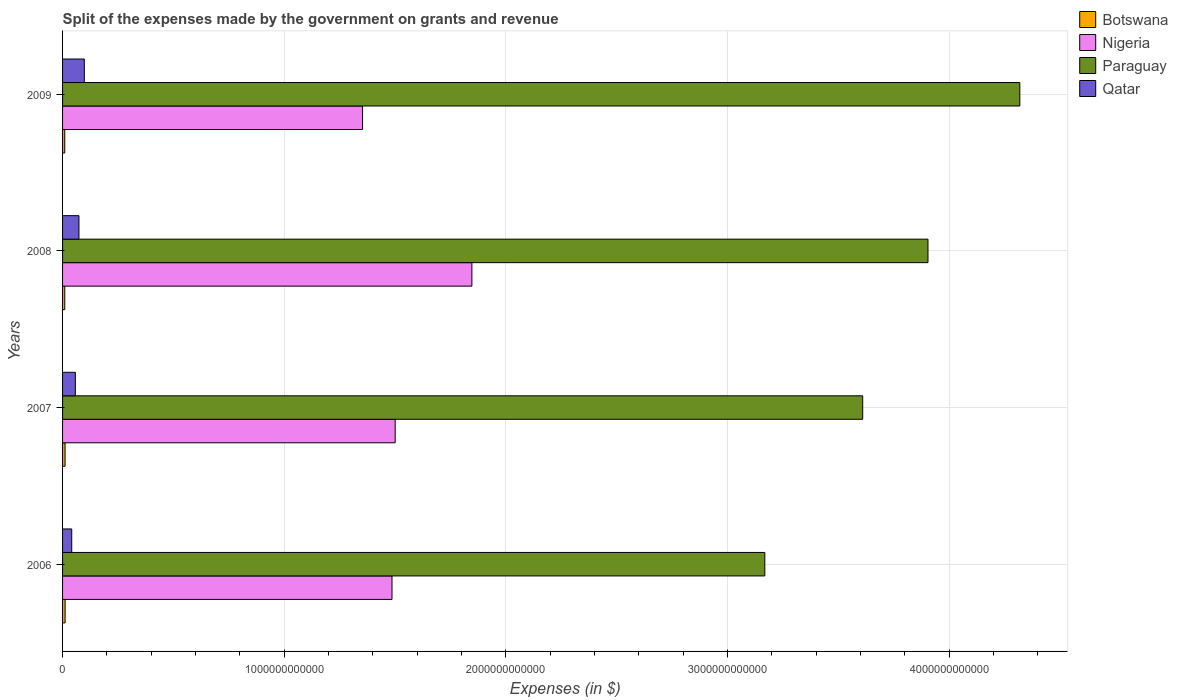Are the number of bars on each tick of the Y-axis equal?
Keep it short and to the point. Yes. How many bars are there on the 1st tick from the top?
Keep it short and to the point. 4. How many bars are there on the 3rd tick from the bottom?
Offer a very short reply. 4. What is the expenses made by the government on grants and revenue in Paraguay in 2007?
Make the answer very short. 3.61e+12. Across all years, what is the maximum expenses made by the government on grants and revenue in Paraguay?
Offer a terse response. 4.32e+12. Across all years, what is the minimum expenses made by the government on grants and revenue in Botswana?
Offer a terse response. 9.87e+09. What is the total expenses made by the government on grants and revenue in Nigeria in the graph?
Your response must be concise. 6.19e+12. What is the difference between the expenses made by the government on grants and revenue in Qatar in 2008 and that in 2009?
Your answer should be compact. -2.42e+1. What is the difference between the expenses made by the government on grants and revenue in Qatar in 2009 and the expenses made by the government on grants and revenue in Nigeria in 2008?
Provide a short and direct response. -1.75e+12. What is the average expenses made by the government on grants and revenue in Paraguay per year?
Provide a short and direct response. 3.75e+12. In the year 2009, what is the difference between the expenses made by the government on grants and revenue in Nigeria and expenses made by the government on grants and revenue in Botswana?
Offer a terse response. 1.34e+12. What is the ratio of the expenses made by the government on grants and revenue in Paraguay in 2006 to that in 2009?
Ensure brevity in your answer.  0.73. Is the difference between the expenses made by the government on grants and revenue in Nigeria in 2007 and 2009 greater than the difference between the expenses made by the government on grants and revenue in Botswana in 2007 and 2009?
Offer a very short reply. Yes. What is the difference between the highest and the second highest expenses made by the government on grants and revenue in Botswana?
Your response must be concise. 1.78e+08. What is the difference between the highest and the lowest expenses made by the government on grants and revenue in Nigeria?
Your response must be concise. 4.93e+11. In how many years, is the expenses made by the government on grants and revenue in Qatar greater than the average expenses made by the government on grants and revenue in Qatar taken over all years?
Offer a terse response. 2. Is it the case that in every year, the sum of the expenses made by the government on grants and revenue in Botswana and expenses made by the government on grants and revenue in Nigeria is greater than the sum of expenses made by the government on grants and revenue in Paraguay and expenses made by the government on grants and revenue in Qatar?
Provide a short and direct response. Yes. What does the 3rd bar from the top in 2007 represents?
Keep it short and to the point. Nigeria. What does the 2nd bar from the bottom in 2009 represents?
Your answer should be compact. Nigeria. Are all the bars in the graph horizontal?
Your answer should be compact. Yes. What is the difference between two consecutive major ticks on the X-axis?
Offer a very short reply. 1.00e+12. Are the values on the major ticks of X-axis written in scientific E-notation?
Give a very brief answer. No. Where does the legend appear in the graph?
Make the answer very short. Top right. How are the legend labels stacked?
Offer a very short reply. Vertical. What is the title of the graph?
Your answer should be very brief. Split of the expenses made by the government on grants and revenue. What is the label or title of the X-axis?
Give a very brief answer. Expenses (in $). What is the label or title of the Y-axis?
Your answer should be very brief. Years. What is the Expenses (in $) in Botswana in 2006?
Make the answer very short. 1.14e+1. What is the Expenses (in $) of Nigeria in 2006?
Your response must be concise. 1.49e+12. What is the Expenses (in $) of Paraguay in 2006?
Make the answer very short. 3.17e+12. What is the Expenses (in $) of Qatar in 2006?
Your answer should be very brief. 4.14e+1. What is the Expenses (in $) in Botswana in 2007?
Your answer should be very brief. 1.13e+1. What is the Expenses (in $) in Nigeria in 2007?
Keep it short and to the point. 1.50e+12. What is the Expenses (in $) of Paraguay in 2007?
Give a very brief answer. 3.61e+12. What is the Expenses (in $) of Qatar in 2007?
Offer a very short reply. 5.77e+1. What is the Expenses (in $) of Botswana in 2008?
Provide a short and direct response. 9.89e+09. What is the Expenses (in $) in Nigeria in 2008?
Ensure brevity in your answer.  1.85e+12. What is the Expenses (in $) in Paraguay in 2008?
Offer a very short reply. 3.91e+12. What is the Expenses (in $) in Qatar in 2008?
Provide a succinct answer. 7.40e+1. What is the Expenses (in $) of Botswana in 2009?
Provide a short and direct response. 9.87e+09. What is the Expenses (in $) in Nigeria in 2009?
Offer a very short reply. 1.35e+12. What is the Expenses (in $) of Paraguay in 2009?
Your answer should be very brief. 4.32e+12. What is the Expenses (in $) in Qatar in 2009?
Offer a terse response. 9.81e+1. Across all years, what is the maximum Expenses (in $) in Botswana?
Your answer should be compact. 1.14e+1. Across all years, what is the maximum Expenses (in $) in Nigeria?
Offer a terse response. 1.85e+12. Across all years, what is the maximum Expenses (in $) of Paraguay?
Your answer should be compact. 4.32e+12. Across all years, what is the maximum Expenses (in $) of Qatar?
Offer a very short reply. 9.81e+1. Across all years, what is the minimum Expenses (in $) of Botswana?
Make the answer very short. 9.87e+09. Across all years, what is the minimum Expenses (in $) in Nigeria?
Ensure brevity in your answer.  1.35e+12. Across all years, what is the minimum Expenses (in $) of Paraguay?
Your answer should be very brief. 3.17e+12. Across all years, what is the minimum Expenses (in $) of Qatar?
Provide a short and direct response. 4.14e+1. What is the total Expenses (in $) in Botswana in the graph?
Offer a very short reply. 4.25e+1. What is the total Expenses (in $) in Nigeria in the graph?
Offer a terse response. 6.19e+12. What is the total Expenses (in $) of Paraguay in the graph?
Your answer should be very brief. 1.50e+13. What is the total Expenses (in $) in Qatar in the graph?
Offer a very short reply. 2.71e+11. What is the difference between the Expenses (in $) of Botswana in 2006 and that in 2007?
Offer a very short reply. 1.78e+08. What is the difference between the Expenses (in $) in Nigeria in 2006 and that in 2007?
Make the answer very short. -1.44e+1. What is the difference between the Expenses (in $) in Paraguay in 2006 and that in 2007?
Give a very brief answer. -4.42e+11. What is the difference between the Expenses (in $) in Qatar in 2006 and that in 2007?
Provide a short and direct response. -1.64e+1. What is the difference between the Expenses (in $) of Botswana in 2006 and that in 2008?
Your answer should be compact. 1.55e+09. What is the difference between the Expenses (in $) in Nigeria in 2006 and that in 2008?
Your answer should be very brief. -3.60e+11. What is the difference between the Expenses (in $) of Paraguay in 2006 and that in 2008?
Provide a succinct answer. -7.36e+11. What is the difference between the Expenses (in $) in Qatar in 2006 and that in 2008?
Provide a succinct answer. -3.26e+1. What is the difference between the Expenses (in $) of Botswana in 2006 and that in 2009?
Make the answer very short. 1.57e+09. What is the difference between the Expenses (in $) of Nigeria in 2006 and that in 2009?
Ensure brevity in your answer.  1.33e+11. What is the difference between the Expenses (in $) in Paraguay in 2006 and that in 2009?
Keep it short and to the point. -1.15e+12. What is the difference between the Expenses (in $) of Qatar in 2006 and that in 2009?
Give a very brief answer. -5.68e+1. What is the difference between the Expenses (in $) of Botswana in 2007 and that in 2008?
Your answer should be compact. 1.37e+09. What is the difference between the Expenses (in $) in Nigeria in 2007 and that in 2008?
Give a very brief answer. -3.46e+11. What is the difference between the Expenses (in $) of Paraguay in 2007 and that in 2008?
Your response must be concise. -2.95e+11. What is the difference between the Expenses (in $) in Qatar in 2007 and that in 2008?
Your answer should be compact. -1.62e+1. What is the difference between the Expenses (in $) of Botswana in 2007 and that in 2009?
Keep it short and to the point. 1.39e+09. What is the difference between the Expenses (in $) of Nigeria in 2007 and that in 2009?
Ensure brevity in your answer.  1.47e+11. What is the difference between the Expenses (in $) of Paraguay in 2007 and that in 2009?
Provide a short and direct response. -7.09e+11. What is the difference between the Expenses (in $) in Qatar in 2007 and that in 2009?
Your answer should be compact. -4.04e+1. What is the difference between the Expenses (in $) of Botswana in 2008 and that in 2009?
Provide a short and direct response. 1.95e+07. What is the difference between the Expenses (in $) of Nigeria in 2008 and that in 2009?
Keep it short and to the point. 4.93e+11. What is the difference between the Expenses (in $) of Paraguay in 2008 and that in 2009?
Give a very brief answer. -4.14e+11. What is the difference between the Expenses (in $) of Qatar in 2008 and that in 2009?
Your answer should be very brief. -2.42e+1. What is the difference between the Expenses (in $) of Botswana in 2006 and the Expenses (in $) of Nigeria in 2007?
Your answer should be very brief. -1.49e+12. What is the difference between the Expenses (in $) in Botswana in 2006 and the Expenses (in $) in Paraguay in 2007?
Your response must be concise. -3.60e+12. What is the difference between the Expenses (in $) of Botswana in 2006 and the Expenses (in $) of Qatar in 2007?
Provide a succinct answer. -4.63e+1. What is the difference between the Expenses (in $) in Nigeria in 2006 and the Expenses (in $) in Paraguay in 2007?
Ensure brevity in your answer.  -2.12e+12. What is the difference between the Expenses (in $) of Nigeria in 2006 and the Expenses (in $) of Qatar in 2007?
Provide a succinct answer. 1.43e+12. What is the difference between the Expenses (in $) in Paraguay in 2006 and the Expenses (in $) in Qatar in 2007?
Keep it short and to the point. 3.11e+12. What is the difference between the Expenses (in $) in Botswana in 2006 and the Expenses (in $) in Nigeria in 2008?
Your answer should be compact. -1.84e+12. What is the difference between the Expenses (in $) of Botswana in 2006 and the Expenses (in $) of Paraguay in 2008?
Ensure brevity in your answer.  -3.89e+12. What is the difference between the Expenses (in $) in Botswana in 2006 and the Expenses (in $) in Qatar in 2008?
Keep it short and to the point. -6.25e+1. What is the difference between the Expenses (in $) of Nigeria in 2006 and the Expenses (in $) of Paraguay in 2008?
Offer a terse response. -2.42e+12. What is the difference between the Expenses (in $) in Nigeria in 2006 and the Expenses (in $) in Qatar in 2008?
Make the answer very short. 1.41e+12. What is the difference between the Expenses (in $) in Paraguay in 2006 and the Expenses (in $) in Qatar in 2008?
Offer a terse response. 3.09e+12. What is the difference between the Expenses (in $) in Botswana in 2006 and the Expenses (in $) in Nigeria in 2009?
Keep it short and to the point. -1.34e+12. What is the difference between the Expenses (in $) in Botswana in 2006 and the Expenses (in $) in Paraguay in 2009?
Make the answer very short. -4.31e+12. What is the difference between the Expenses (in $) in Botswana in 2006 and the Expenses (in $) in Qatar in 2009?
Provide a short and direct response. -8.67e+1. What is the difference between the Expenses (in $) in Nigeria in 2006 and the Expenses (in $) in Paraguay in 2009?
Provide a succinct answer. -2.83e+12. What is the difference between the Expenses (in $) of Nigeria in 2006 and the Expenses (in $) of Qatar in 2009?
Your answer should be very brief. 1.39e+12. What is the difference between the Expenses (in $) of Paraguay in 2006 and the Expenses (in $) of Qatar in 2009?
Provide a short and direct response. 3.07e+12. What is the difference between the Expenses (in $) of Botswana in 2007 and the Expenses (in $) of Nigeria in 2008?
Offer a terse response. -1.84e+12. What is the difference between the Expenses (in $) of Botswana in 2007 and the Expenses (in $) of Paraguay in 2008?
Give a very brief answer. -3.89e+12. What is the difference between the Expenses (in $) of Botswana in 2007 and the Expenses (in $) of Qatar in 2008?
Make the answer very short. -6.27e+1. What is the difference between the Expenses (in $) of Nigeria in 2007 and the Expenses (in $) of Paraguay in 2008?
Your answer should be very brief. -2.40e+12. What is the difference between the Expenses (in $) of Nigeria in 2007 and the Expenses (in $) of Qatar in 2008?
Offer a very short reply. 1.43e+12. What is the difference between the Expenses (in $) of Paraguay in 2007 and the Expenses (in $) of Qatar in 2008?
Give a very brief answer. 3.54e+12. What is the difference between the Expenses (in $) of Botswana in 2007 and the Expenses (in $) of Nigeria in 2009?
Give a very brief answer. -1.34e+12. What is the difference between the Expenses (in $) of Botswana in 2007 and the Expenses (in $) of Paraguay in 2009?
Offer a terse response. -4.31e+12. What is the difference between the Expenses (in $) of Botswana in 2007 and the Expenses (in $) of Qatar in 2009?
Make the answer very short. -8.69e+1. What is the difference between the Expenses (in $) of Nigeria in 2007 and the Expenses (in $) of Paraguay in 2009?
Your response must be concise. -2.82e+12. What is the difference between the Expenses (in $) of Nigeria in 2007 and the Expenses (in $) of Qatar in 2009?
Offer a very short reply. 1.40e+12. What is the difference between the Expenses (in $) of Paraguay in 2007 and the Expenses (in $) of Qatar in 2009?
Offer a very short reply. 3.51e+12. What is the difference between the Expenses (in $) of Botswana in 2008 and the Expenses (in $) of Nigeria in 2009?
Give a very brief answer. -1.34e+12. What is the difference between the Expenses (in $) of Botswana in 2008 and the Expenses (in $) of Paraguay in 2009?
Ensure brevity in your answer.  -4.31e+12. What is the difference between the Expenses (in $) of Botswana in 2008 and the Expenses (in $) of Qatar in 2009?
Offer a terse response. -8.83e+1. What is the difference between the Expenses (in $) in Nigeria in 2008 and the Expenses (in $) in Paraguay in 2009?
Offer a very short reply. -2.47e+12. What is the difference between the Expenses (in $) of Nigeria in 2008 and the Expenses (in $) of Qatar in 2009?
Your response must be concise. 1.75e+12. What is the difference between the Expenses (in $) in Paraguay in 2008 and the Expenses (in $) in Qatar in 2009?
Your answer should be compact. 3.81e+12. What is the average Expenses (in $) in Botswana per year?
Your answer should be very brief. 1.06e+1. What is the average Expenses (in $) of Nigeria per year?
Provide a short and direct response. 1.55e+12. What is the average Expenses (in $) of Paraguay per year?
Your answer should be compact. 3.75e+12. What is the average Expenses (in $) in Qatar per year?
Your answer should be compact. 6.78e+1. In the year 2006, what is the difference between the Expenses (in $) in Botswana and Expenses (in $) in Nigeria?
Provide a short and direct response. -1.48e+12. In the year 2006, what is the difference between the Expenses (in $) of Botswana and Expenses (in $) of Paraguay?
Give a very brief answer. -3.16e+12. In the year 2006, what is the difference between the Expenses (in $) of Botswana and Expenses (in $) of Qatar?
Make the answer very short. -2.99e+1. In the year 2006, what is the difference between the Expenses (in $) of Nigeria and Expenses (in $) of Paraguay?
Your answer should be compact. -1.68e+12. In the year 2006, what is the difference between the Expenses (in $) in Nigeria and Expenses (in $) in Qatar?
Your response must be concise. 1.45e+12. In the year 2006, what is the difference between the Expenses (in $) of Paraguay and Expenses (in $) of Qatar?
Make the answer very short. 3.13e+12. In the year 2007, what is the difference between the Expenses (in $) in Botswana and Expenses (in $) in Nigeria?
Your answer should be very brief. -1.49e+12. In the year 2007, what is the difference between the Expenses (in $) in Botswana and Expenses (in $) in Paraguay?
Provide a succinct answer. -3.60e+12. In the year 2007, what is the difference between the Expenses (in $) in Botswana and Expenses (in $) in Qatar?
Offer a very short reply. -4.65e+1. In the year 2007, what is the difference between the Expenses (in $) of Nigeria and Expenses (in $) of Paraguay?
Make the answer very short. -2.11e+12. In the year 2007, what is the difference between the Expenses (in $) in Nigeria and Expenses (in $) in Qatar?
Give a very brief answer. 1.44e+12. In the year 2007, what is the difference between the Expenses (in $) of Paraguay and Expenses (in $) of Qatar?
Your answer should be compact. 3.55e+12. In the year 2008, what is the difference between the Expenses (in $) of Botswana and Expenses (in $) of Nigeria?
Your answer should be compact. -1.84e+12. In the year 2008, what is the difference between the Expenses (in $) in Botswana and Expenses (in $) in Paraguay?
Offer a very short reply. -3.90e+12. In the year 2008, what is the difference between the Expenses (in $) in Botswana and Expenses (in $) in Qatar?
Offer a very short reply. -6.41e+1. In the year 2008, what is the difference between the Expenses (in $) in Nigeria and Expenses (in $) in Paraguay?
Make the answer very short. -2.06e+12. In the year 2008, what is the difference between the Expenses (in $) of Nigeria and Expenses (in $) of Qatar?
Your response must be concise. 1.77e+12. In the year 2008, what is the difference between the Expenses (in $) of Paraguay and Expenses (in $) of Qatar?
Offer a terse response. 3.83e+12. In the year 2009, what is the difference between the Expenses (in $) of Botswana and Expenses (in $) of Nigeria?
Ensure brevity in your answer.  -1.34e+12. In the year 2009, what is the difference between the Expenses (in $) in Botswana and Expenses (in $) in Paraguay?
Offer a terse response. -4.31e+12. In the year 2009, what is the difference between the Expenses (in $) in Botswana and Expenses (in $) in Qatar?
Provide a succinct answer. -8.83e+1. In the year 2009, what is the difference between the Expenses (in $) of Nigeria and Expenses (in $) of Paraguay?
Offer a very short reply. -2.97e+12. In the year 2009, what is the difference between the Expenses (in $) in Nigeria and Expenses (in $) in Qatar?
Your answer should be very brief. 1.26e+12. In the year 2009, what is the difference between the Expenses (in $) in Paraguay and Expenses (in $) in Qatar?
Your answer should be very brief. 4.22e+12. What is the ratio of the Expenses (in $) in Botswana in 2006 to that in 2007?
Your response must be concise. 1.02. What is the ratio of the Expenses (in $) of Nigeria in 2006 to that in 2007?
Your answer should be compact. 0.99. What is the ratio of the Expenses (in $) in Paraguay in 2006 to that in 2007?
Ensure brevity in your answer.  0.88. What is the ratio of the Expenses (in $) in Qatar in 2006 to that in 2007?
Your answer should be compact. 0.72. What is the ratio of the Expenses (in $) of Botswana in 2006 to that in 2008?
Give a very brief answer. 1.16. What is the ratio of the Expenses (in $) in Nigeria in 2006 to that in 2008?
Your answer should be compact. 0.8. What is the ratio of the Expenses (in $) of Paraguay in 2006 to that in 2008?
Make the answer very short. 0.81. What is the ratio of the Expenses (in $) of Qatar in 2006 to that in 2008?
Offer a very short reply. 0.56. What is the ratio of the Expenses (in $) of Botswana in 2006 to that in 2009?
Provide a short and direct response. 1.16. What is the ratio of the Expenses (in $) in Nigeria in 2006 to that in 2009?
Your answer should be very brief. 1.1. What is the ratio of the Expenses (in $) of Paraguay in 2006 to that in 2009?
Keep it short and to the point. 0.73. What is the ratio of the Expenses (in $) of Qatar in 2006 to that in 2009?
Ensure brevity in your answer.  0.42. What is the ratio of the Expenses (in $) in Botswana in 2007 to that in 2008?
Your response must be concise. 1.14. What is the ratio of the Expenses (in $) in Nigeria in 2007 to that in 2008?
Your answer should be very brief. 0.81. What is the ratio of the Expenses (in $) of Paraguay in 2007 to that in 2008?
Give a very brief answer. 0.92. What is the ratio of the Expenses (in $) in Qatar in 2007 to that in 2008?
Provide a short and direct response. 0.78. What is the ratio of the Expenses (in $) of Botswana in 2007 to that in 2009?
Give a very brief answer. 1.14. What is the ratio of the Expenses (in $) in Nigeria in 2007 to that in 2009?
Your answer should be very brief. 1.11. What is the ratio of the Expenses (in $) in Paraguay in 2007 to that in 2009?
Ensure brevity in your answer.  0.84. What is the ratio of the Expenses (in $) in Qatar in 2007 to that in 2009?
Make the answer very short. 0.59. What is the ratio of the Expenses (in $) of Nigeria in 2008 to that in 2009?
Offer a very short reply. 1.36. What is the ratio of the Expenses (in $) in Paraguay in 2008 to that in 2009?
Offer a very short reply. 0.9. What is the ratio of the Expenses (in $) of Qatar in 2008 to that in 2009?
Give a very brief answer. 0.75. What is the difference between the highest and the second highest Expenses (in $) in Botswana?
Keep it short and to the point. 1.78e+08. What is the difference between the highest and the second highest Expenses (in $) of Nigeria?
Your answer should be very brief. 3.46e+11. What is the difference between the highest and the second highest Expenses (in $) in Paraguay?
Make the answer very short. 4.14e+11. What is the difference between the highest and the second highest Expenses (in $) in Qatar?
Keep it short and to the point. 2.42e+1. What is the difference between the highest and the lowest Expenses (in $) of Botswana?
Provide a short and direct response. 1.57e+09. What is the difference between the highest and the lowest Expenses (in $) of Nigeria?
Make the answer very short. 4.93e+11. What is the difference between the highest and the lowest Expenses (in $) in Paraguay?
Make the answer very short. 1.15e+12. What is the difference between the highest and the lowest Expenses (in $) of Qatar?
Make the answer very short. 5.68e+1. 